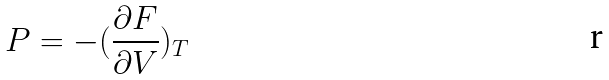<formula> <loc_0><loc_0><loc_500><loc_500>P = - ( \frac { \partial F } { \partial V } ) _ { T }</formula> 